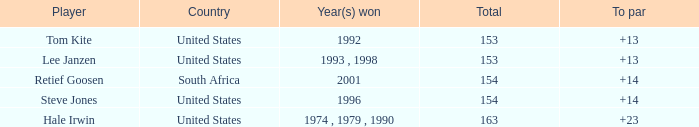What was the year when the united states had a to par exceeding 14? 1974 , 1979 , 1990. 